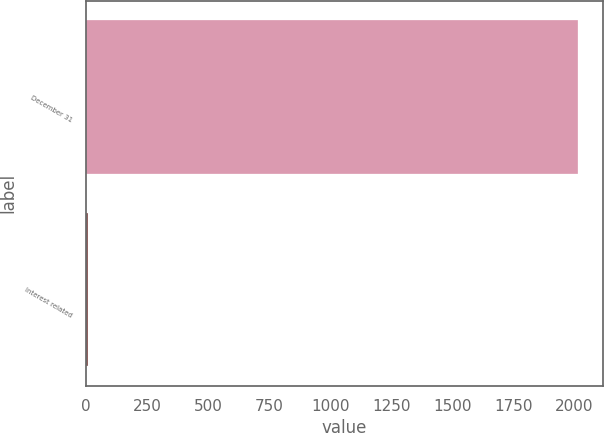Convert chart to OTSL. <chart><loc_0><loc_0><loc_500><loc_500><bar_chart><fcel>December 31<fcel>Interest related<nl><fcel>2017<fcel>7<nl></chart> 